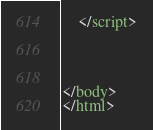<code> <loc_0><loc_0><loc_500><loc_500><_HTML_>
    </script>




</body>
</html>
</code> 